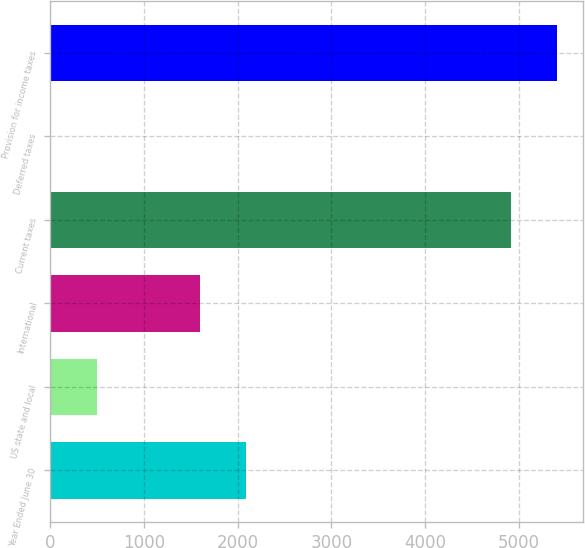<chart> <loc_0><loc_0><loc_500><loc_500><bar_chart><fcel>Year Ended June 30<fcel>US state and local<fcel>International<fcel>Current taxes<fcel>Deferred taxes<fcel>Provision for income taxes<nl><fcel>2093.9<fcel>493.9<fcel>1602<fcel>4919<fcel>2<fcel>5410.9<nl></chart> 